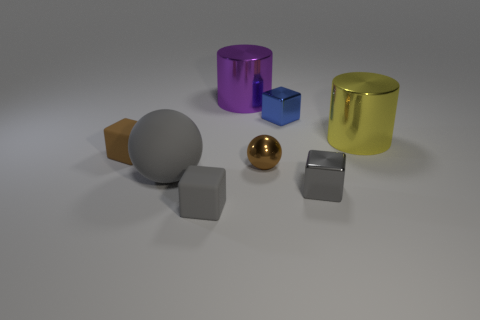Can you describe the color and material characteristics of the objects in the image? Certainly! The objects in the image exhibit a variety of hues and finish types. The large cylinder on the right has a metallic gold finish with a reflective surface, while the big cylinder in the middle shows a glossy, reflective purple surface. The small sphere and one of the cubes have a shiny metallic finish, with the sphere displaying a reflective golden color and the cube showcasing a polished silver tone. Another cube appears matte with a grey tone, and the small object resembling a truncated pyramid presents a matte brown surface. These material characteristics suggest the objects are metallic, with some having a reflective polished surface and others showing a duller, matte finish. 